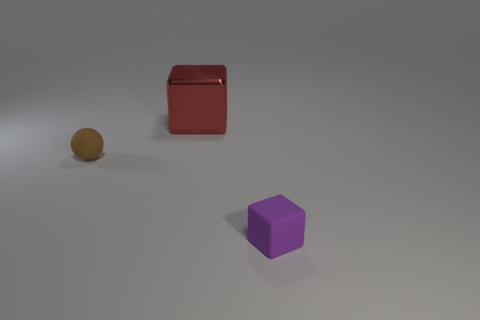Is there any other thing that is the same size as the red shiny thing?
Provide a succinct answer. No. Is there anything else that is the same material as the red thing?
Offer a very short reply. No. How many other objects are there of the same material as the red block?
Your response must be concise. 0. What number of big things are either red blocks or purple objects?
Give a very brief answer. 1. Is the number of red things that are behind the brown object the same as the number of big blocks?
Your response must be concise. Yes. There is a matte object that is behind the small purple rubber cube; is there a matte sphere that is to the right of it?
Offer a very short reply. No. How many other objects are the same color as the large shiny object?
Offer a terse response. 0. The large metallic cube has what color?
Give a very brief answer. Red. There is a object that is both in front of the metallic object and on the right side of the brown matte object; what is its size?
Provide a short and direct response. Small. What number of objects are large red blocks that are to the right of the brown matte thing or red shiny objects?
Keep it short and to the point. 1. 